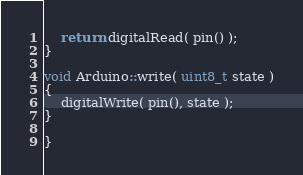<code> <loc_0><loc_0><loc_500><loc_500><_C++_>	return digitalRead( pin() );
}

void Arduino::write( uint8_t state )
{
	digitalWrite( pin(), state );
}

}</code> 